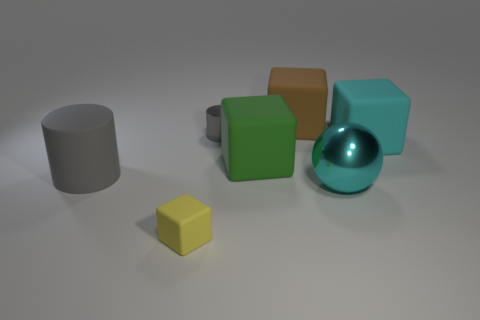What is the lighting condition in the scene depicted in this image? The image portrays a softly lit environment with diffused light coming from above, casting subtle shadows beneath the objects, suggesting an indoor setting with ambient lighting. 